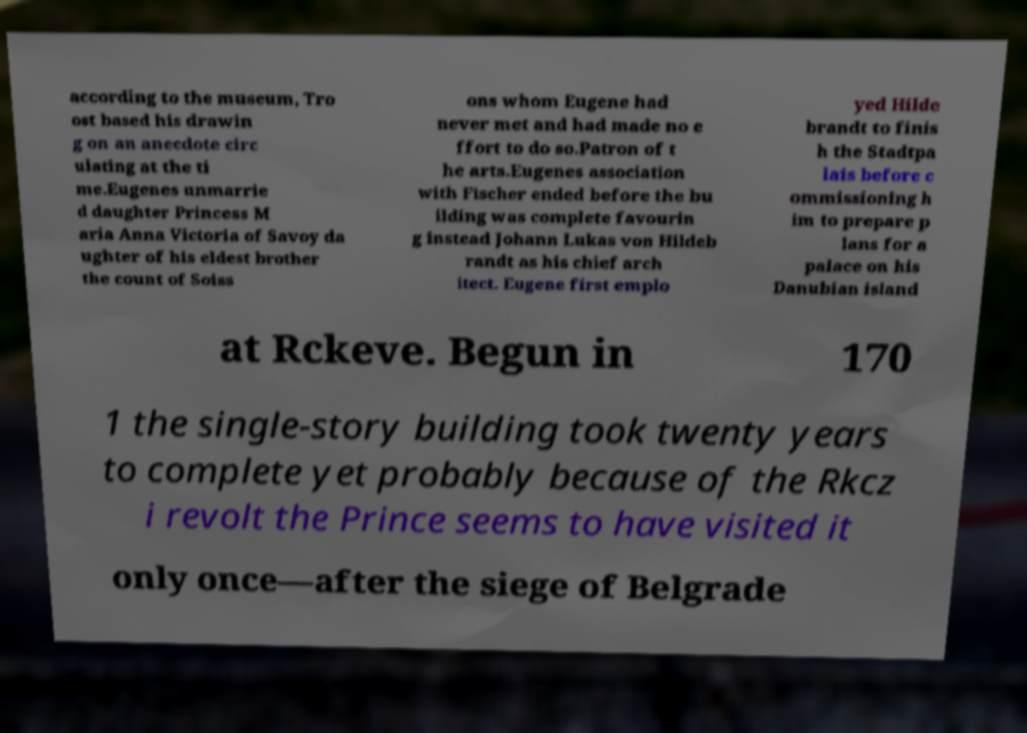Can you read and provide the text displayed in the image?This photo seems to have some interesting text. Can you extract and type it out for me? according to the museum, Tro ost based his drawin g on an anecdote circ ulating at the ti me.Eugenes unmarrie d daughter Princess M aria Anna Victoria of Savoy da ughter of his eldest brother the count of Soiss ons whom Eugene had never met and had made no e ffort to do so.Patron of t he arts.Eugenes association with Fischer ended before the bu ilding was complete favourin g instead Johann Lukas von Hildeb randt as his chief arch itect. Eugene first emplo yed Hilde brandt to finis h the Stadtpa lais before c ommissioning h im to prepare p lans for a palace on his Danubian island at Rckeve. Begun in 170 1 the single-story building took twenty years to complete yet probably because of the Rkcz i revolt the Prince seems to have visited it only once—after the siege of Belgrade 